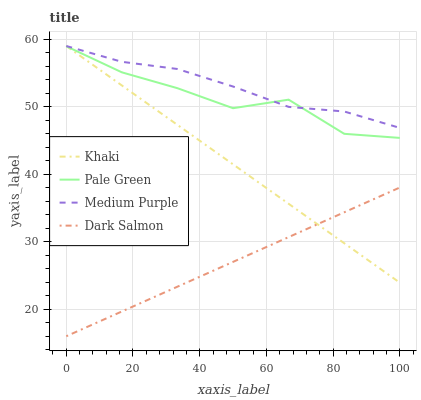Does Dark Salmon have the minimum area under the curve?
Answer yes or no. Yes. Does Medium Purple have the maximum area under the curve?
Answer yes or no. Yes. Does Pale Green have the minimum area under the curve?
Answer yes or no. No. Does Pale Green have the maximum area under the curve?
Answer yes or no. No. Is Khaki the smoothest?
Answer yes or no. Yes. Is Pale Green the roughest?
Answer yes or no. Yes. Is Pale Green the smoothest?
Answer yes or no. No. Is Khaki the roughest?
Answer yes or no. No. Does Dark Salmon have the lowest value?
Answer yes or no. Yes. Does Pale Green have the lowest value?
Answer yes or no. No. Does Khaki have the highest value?
Answer yes or no. Yes. Does Pale Green have the highest value?
Answer yes or no. No. Is Dark Salmon less than Pale Green?
Answer yes or no. Yes. Is Medium Purple greater than Dark Salmon?
Answer yes or no. Yes. Does Pale Green intersect Khaki?
Answer yes or no. Yes. Is Pale Green less than Khaki?
Answer yes or no. No. Is Pale Green greater than Khaki?
Answer yes or no. No. Does Dark Salmon intersect Pale Green?
Answer yes or no. No. 